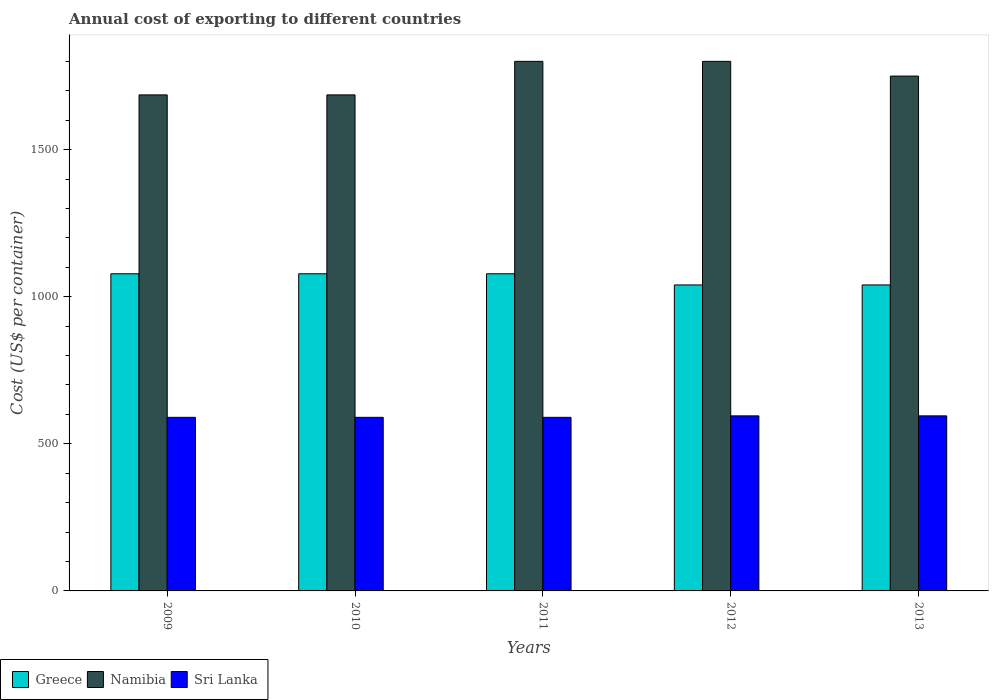How many bars are there on the 1st tick from the right?
Provide a succinct answer. 3. In how many cases, is the number of bars for a given year not equal to the number of legend labels?
Your answer should be compact. 0. What is the total annual cost of exporting in Namibia in 2013?
Give a very brief answer. 1750. Across all years, what is the maximum total annual cost of exporting in Sri Lanka?
Keep it short and to the point. 595. Across all years, what is the minimum total annual cost of exporting in Sri Lanka?
Your answer should be very brief. 590. In which year was the total annual cost of exporting in Namibia maximum?
Offer a very short reply. 2011. In which year was the total annual cost of exporting in Greece minimum?
Your answer should be very brief. 2012. What is the total total annual cost of exporting in Sri Lanka in the graph?
Offer a terse response. 2960. What is the difference between the total annual cost of exporting in Namibia in 2012 and that in 2013?
Keep it short and to the point. 50. What is the difference between the total annual cost of exporting in Namibia in 2011 and the total annual cost of exporting in Sri Lanka in 2009?
Offer a very short reply. 1210. What is the average total annual cost of exporting in Sri Lanka per year?
Make the answer very short. 592. In the year 2010, what is the difference between the total annual cost of exporting in Sri Lanka and total annual cost of exporting in Namibia?
Give a very brief answer. -1096. What is the ratio of the total annual cost of exporting in Sri Lanka in 2011 to that in 2013?
Keep it short and to the point. 0.99. Is the difference between the total annual cost of exporting in Sri Lanka in 2009 and 2011 greater than the difference between the total annual cost of exporting in Namibia in 2009 and 2011?
Your response must be concise. Yes. What is the difference between the highest and the lowest total annual cost of exporting in Greece?
Give a very brief answer. 38. In how many years, is the total annual cost of exporting in Namibia greater than the average total annual cost of exporting in Namibia taken over all years?
Your answer should be compact. 3. What does the 2nd bar from the left in 2013 represents?
Offer a terse response. Namibia. What does the 1st bar from the right in 2010 represents?
Make the answer very short. Sri Lanka. Is it the case that in every year, the sum of the total annual cost of exporting in Namibia and total annual cost of exporting in Greece is greater than the total annual cost of exporting in Sri Lanka?
Provide a short and direct response. Yes. Are all the bars in the graph horizontal?
Your response must be concise. No. What is the difference between two consecutive major ticks on the Y-axis?
Offer a terse response. 500. Are the values on the major ticks of Y-axis written in scientific E-notation?
Your answer should be compact. No. Where does the legend appear in the graph?
Offer a terse response. Bottom left. How many legend labels are there?
Make the answer very short. 3. How are the legend labels stacked?
Ensure brevity in your answer.  Horizontal. What is the title of the graph?
Ensure brevity in your answer.  Annual cost of exporting to different countries. What is the label or title of the Y-axis?
Provide a succinct answer. Cost (US$ per container). What is the Cost (US$ per container) in Greece in 2009?
Keep it short and to the point. 1078. What is the Cost (US$ per container) in Namibia in 2009?
Your answer should be compact. 1686. What is the Cost (US$ per container) of Sri Lanka in 2009?
Ensure brevity in your answer.  590. What is the Cost (US$ per container) of Greece in 2010?
Give a very brief answer. 1078. What is the Cost (US$ per container) of Namibia in 2010?
Your response must be concise. 1686. What is the Cost (US$ per container) in Sri Lanka in 2010?
Make the answer very short. 590. What is the Cost (US$ per container) of Greece in 2011?
Ensure brevity in your answer.  1078. What is the Cost (US$ per container) of Namibia in 2011?
Your answer should be compact. 1800. What is the Cost (US$ per container) of Sri Lanka in 2011?
Keep it short and to the point. 590. What is the Cost (US$ per container) of Greece in 2012?
Give a very brief answer. 1040. What is the Cost (US$ per container) of Namibia in 2012?
Your answer should be compact. 1800. What is the Cost (US$ per container) in Sri Lanka in 2012?
Keep it short and to the point. 595. What is the Cost (US$ per container) of Greece in 2013?
Your answer should be very brief. 1040. What is the Cost (US$ per container) of Namibia in 2013?
Offer a terse response. 1750. What is the Cost (US$ per container) in Sri Lanka in 2013?
Offer a terse response. 595. Across all years, what is the maximum Cost (US$ per container) of Greece?
Your response must be concise. 1078. Across all years, what is the maximum Cost (US$ per container) of Namibia?
Provide a succinct answer. 1800. Across all years, what is the maximum Cost (US$ per container) in Sri Lanka?
Keep it short and to the point. 595. Across all years, what is the minimum Cost (US$ per container) in Greece?
Offer a terse response. 1040. Across all years, what is the minimum Cost (US$ per container) in Namibia?
Your answer should be compact. 1686. Across all years, what is the minimum Cost (US$ per container) in Sri Lanka?
Your answer should be very brief. 590. What is the total Cost (US$ per container) in Greece in the graph?
Offer a terse response. 5314. What is the total Cost (US$ per container) of Namibia in the graph?
Give a very brief answer. 8722. What is the total Cost (US$ per container) of Sri Lanka in the graph?
Offer a very short reply. 2960. What is the difference between the Cost (US$ per container) of Namibia in 2009 and that in 2011?
Your response must be concise. -114. What is the difference between the Cost (US$ per container) of Sri Lanka in 2009 and that in 2011?
Provide a short and direct response. 0. What is the difference between the Cost (US$ per container) of Greece in 2009 and that in 2012?
Your answer should be compact. 38. What is the difference between the Cost (US$ per container) in Namibia in 2009 and that in 2012?
Your response must be concise. -114. What is the difference between the Cost (US$ per container) in Greece in 2009 and that in 2013?
Your answer should be very brief. 38. What is the difference between the Cost (US$ per container) in Namibia in 2009 and that in 2013?
Provide a succinct answer. -64. What is the difference between the Cost (US$ per container) in Namibia in 2010 and that in 2011?
Provide a short and direct response. -114. What is the difference between the Cost (US$ per container) of Namibia in 2010 and that in 2012?
Provide a succinct answer. -114. What is the difference between the Cost (US$ per container) of Sri Lanka in 2010 and that in 2012?
Provide a short and direct response. -5. What is the difference between the Cost (US$ per container) of Greece in 2010 and that in 2013?
Provide a short and direct response. 38. What is the difference between the Cost (US$ per container) of Namibia in 2010 and that in 2013?
Make the answer very short. -64. What is the difference between the Cost (US$ per container) in Sri Lanka in 2010 and that in 2013?
Keep it short and to the point. -5. What is the difference between the Cost (US$ per container) in Greece in 2011 and that in 2012?
Your answer should be very brief. 38. What is the difference between the Cost (US$ per container) in Greece in 2011 and that in 2013?
Your answer should be compact. 38. What is the difference between the Cost (US$ per container) of Namibia in 2011 and that in 2013?
Ensure brevity in your answer.  50. What is the difference between the Cost (US$ per container) in Sri Lanka in 2011 and that in 2013?
Give a very brief answer. -5. What is the difference between the Cost (US$ per container) in Sri Lanka in 2012 and that in 2013?
Keep it short and to the point. 0. What is the difference between the Cost (US$ per container) of Greece in 2009 and the Cost (US$ per container) of Namibia in 2010?
Make the answer very short. -608. What is the difference between the Cost (US$ per container) in Greece in 2009 and the Cost (US$ per container) in Sri Lanka in 2010?
Ensure brevity in your answer.  488. What is the difference between the Cost (US$ per container) in Namibia in 2009 and the Cost (US$ per container) in Sri Lanka in 2010?
Offer a terse response. 1096. What is the difference between the Cost (US$ per container) of Greece in 2009 and the Cost (US$ per container) of Namibia in 2011?
Offer a terse response. -722. What is the difference between the Cost (US$ per container) of Greece in 2009 and the Cost (US$ per container) of Sri Lanka in 2011?
Your response must be concise. 488. What is the difference between the Cost (US$ per container) of Namibia in 2009 and the Cost (US$ per container) of Sri Lanka in 2011?
Make the answer very short. 1096. What is the difference between the Cost (US$ per container) in Greece in 2009 and the Cost (US$ per container) in Namibia in 2012?
Offer a terse response. -722. What is the difference between the Cost (US$ per container) in Greece in 2009 and the Cost (US$ per container) in Sri Lanka in 2012?
Your answer should be very brief. 483. What is the difference between the Cost (US$ per container) in Namibia in 2009 and the Cost (US$ per container) in Sri Lanka in 2012?
Make the answer very short. 1091. What is the difference between the Cost (US$ per container) of Greece in 2009 and the Cost (US$ per container) of Namibia in 2013?
Make the answer very short. -672. What is the difference between the Cost (US$ per container) of Greece in 2009 and the Cost (US$ per container) of Sri Lanka in 2013?
Offer a very short reply. 483. What is the difference between the Cost (US$ per container) of Namibia in 2009 and the Cost (US$ per container) of Sri Lanka in 2013?
Offer a very short reply. 1091. What is the difference between the Cost (US$ per container) in Greece in 2010 and the Cost (US$ per container) in Namibia in 2011?
Offer a very short reply. -722. What is the difference between the Cost (US$ per container) in Greece in 2010 and the Cost (US$ per container) in Sri Lanka in 2011?
Ensure brevity in your answer.  488. What is the difference between the Cost (US$ per container) in Namibia in 2010 and the Cost (US$ per container) in Sri Lanka in 2011?
Ensure brevity in your answer.  1096. What is the difference between the Cost (US$ per container) of Greece in 2010 and the Cost (US$ per container) of Namibia in 2012?
Offer a terse response. -722. What is the difference between the Cost (US$ per container) of Greece in 2010 and the Cost (US$ per container) of Sri Lanka in 2012?
Make the answer very short. 483. What is the difference between the Cost (US$ per container) of Namibia in 2010 and the Cost (US$ per container) of Sri Lanka in 2012?
Your answer should be very brief. 1091. What is the difference between the Cost (US$ per container) in Greece in 2010 and the Cost (US$ per container) in Namibia in 2013?
Ensure brevity in your answer.  -672. What is the difference between the Cost (US$ per container) of Greece in 2010 and the Cost (US$ per container) of Sri Lanka in 2013?
Your answer should be very brief. 483. What is the difference between the Cost (US$ per container) of Namibia in 2010 and the Cost (US$ per container) of Sri Lanka in 2013?
Offer a terse response. 1091. What is the difference between the Cost (US$ per container) of Greece in 2011 and the Cost (US$ per container) of Namibia in 2012?
Your answer should be compact. -722. What is the difference between the Cost (US$ per container) in Greece in 2011 and the Cost (US$ per container) in Sri Lanka in 2012?
Offer a very short reply. 483. What is the difference between the Cost (US$ per container) of Namibia in 2011 and the Cost (US$ per container) of Sri Lanka in 2012?
Offer a terse response. 1205. What is the difference between the Cost (US$ per container) in Greece in 2011 and the Cost (US$ per container) in Namibia in 2013?
Offer a very short reply. -672. What is the difference between the Cost (US$ per container) of Greece in 2011 and the Cost (US$ per container) of Sri Lanka in 2013?
Your answer should be very brief. 483. What is the difference between the Cost (US$ per container) of Namibia in 2011 and the Cost (US$ per container) of Sri Lanka in 2013?
Provide a succinct answer. 1205. What is the difference between the Cost (US$ per container) in Greece in 2012 and the Cost (US$ per container) in Namibia in 2013?
Your response must be concise. -710. What is the difference between the Cost (US$ per container) of Greece in 2012 and the Cost (US$ per container) of Sri Lanka in 2013?
Ensure brevity in your answer.  445. What is the difference between the Cost (US$ per container) in Namibia in 2012 and the Cost (US$ per container) in Sri Lanka in 2013?
Offer a terse response. 1205. What is the average Cost (US$ per container) in Greece per year?
Your answer should be very brief. 1062.8. What is the average Cost (US$ per container) of Namibia per year?
Provide a succinct answer. 1744.4. What is the average Cost (US$ per container) in Sri Lanka per year?
Your answer should be very brief. 592. In the year 2009, what is the difference between the Cost (US$ per container) in Greece and Cost (US$ per container) in Namibia?
Your response must be concise. -608. In the year 2009, what is the difference between the Cost (US$ per container) of Greece and Cost (US$ per container) of Sri Lanka?
Offer a terse response. 488. In the year 2009, what is the difference between the Cost (US$ per container) in Namibia and Cost (US$ per container) in Sri Lanka?
Offer a terse response. 1096. In the year 2010, what is the difference between the Cost (US$ per container) of Greece and Cost (US$ per container) of Namibia?
Offer a terse response. -608. In the year 2010, what is the difference between the Cost (US$ per container) in Greece and Cost (US$ per container) in Sri Lanka?
Give a very brief answer. 488. In the year 2010, what is the difference between the Cost (US$ per container) in Namibia and Cost (US$ per container) in Sri Lanka?
Provide a short and direct response. 1096. In the year 2011, what is the difference between the Cost (US$ per container) in Greece and Cost (US$ per container) in Namibia?
Make the answer very short. -722. In the year 2011, what is the difference between the Cost (US$ per container) of Greece and Cost (US$ per container) of Sri Lanka?
Your answer should be compact. 488. In the year 2011, what is the difference between the Cost (US$ per container) of Namibia and Cost (US$ per container) of Sri Lanka?
Make the answer very short. 1210. In the year 2012, what is the difference between the Cost (US$ per container) in Greece and Cost (US$ per container) in Namibia?
Your answer should be compact. -760. In the year 2012, what is the difference between the Cost (US$ per container) in Greece and Cost (US$ per container) in Sri Lanka?
Give a very brief answer. 445. In the year 2012, what is the difference between the Cost (US$ per container) of Namibia and Cost (US$ per container) of Sri Lanka?
Ensure brevity in your answer.  1205. In the year 2013, what is the difference between the Cost (US$ per container) in Greece and Cost (US$ per container) in Namibia?
Keep it short and to the point. -710. In the year 2013, what is the difference between the Cost (US$ per container) in Greece and Cost (US$ per container) in Sri Lanka?
Ensure brevity in your answer.  445. In the year 2013, what is the difference between the Cost (US$ per container) of Namibia and Cost (US$ per container) of Sri Lanka?
Your response must be concise. 1155. What is the ratio of the Cost (US$ per container) of Namibia in 2009 to that in 2011?
Your answer should be compact. 0.94. What is the ratio of the Cost (US$ per container) of Greece in 2009 to that in 2012?
Give a very brief answer. 1.04. What is the ratio of the Cost (US$ per container) of Namibia in 2009 to that in 2012?
Offer a terse response. 0.94. What is the ratio of the Cost (US$ per container) of Greece in 2009 to that in 2013?
Offer a very short reply. 1.04. What is the ratio of the Cost (US$ per container) in Namibia in 2009 to that in 2013?
Offer a terse response. 0.96. What is the ratio of the Cost (US$ per container) in Sri Lanka in 2009 to that in 2013?
Give a very brief answer. 0.99. What is the ratio of the Cost (US$ per container) in Greece in 2010 to that in 2011?
Offer a terse response. 1. What is the ratio of the Cost (US$ per container) of Namibia in 2010 to that in 2011?
Your response must be concise. 0.94. What is the ratio of the Cost (US$ per container) of Greece in 2010 to that in 2012?
Offer a very short reply. 1.04. What is the ratio of the Cost (US$ per container) of Namibia in 2010 to that in 2012?
Your answer should be compact. 0.94. What is the ratio of the Cost (US$ per container) in Sri Lanka in 2010 to that in 2012?
Make the answer very short. 0.99. What is the ratio of the Cost (US$ per container) of Greece in 2010 to that in 2013?
Your answer should be very brief. 1.04. What is the ratio of the Cost (US$ per container) of Namibia in 2010 to that in 2013?
Your answer should be compact. 0.96. What is the ratio of the Cost (US$ per container) of Sri Lanka in 2010 to that in 2013?
Your response must be concise. 0.99. What is the ratio of the Cost (US$ per container) in Greece in 2011 to that in 2012?
Give a very brief answer. 1.04. What is the ratio of the Cost (US$ per container) of Namibia in 2011 to that in 2012?
Offer a very short reply. 1. What is the ratio of the Cost (US$ per container) in Greece in 2011 to that in 2013?
Your answer should be very brief. 1.04. What is the ratio of the Cost (US$ per container) of Namibia in 2011 to that in 2013?
Your answer should be very brief. 1.03. What is the ratio of the Cost (US$ per container) in Sri Lanka in 2011 to that in 2013?
Provide a succinct answer. 0.99. What is the ratio of the Cost (US$ per container) of Greece in 2012 to that in 2013?
Offer a very short reply. 1. What is the ratio of the Cost (US$ per container) of Namibia in 2012 to that in 2013?
Offer a terse response. 1.03. What is the difference between the highest and the second highest Cost (US$ per container) in Namibia?
Keep it short and to the point. 0. What is the difference between the highest and the second highest Cost (US$ per container) of Sri Lanka?
Your answer should be compact. 0. What is the difference between the highest and the lowest Cost (US$ per container) in Greece?
Give a very brief answer. 38. What is the difference between the highest and the lowest Cost (US$ per container) of Namibia?
Provide a succinct answer. 114. 